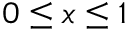Convert formula to latex. <formula><loc_0><loc_0><loc_500><loc_500>0 \leq x \leq 1</formula> 